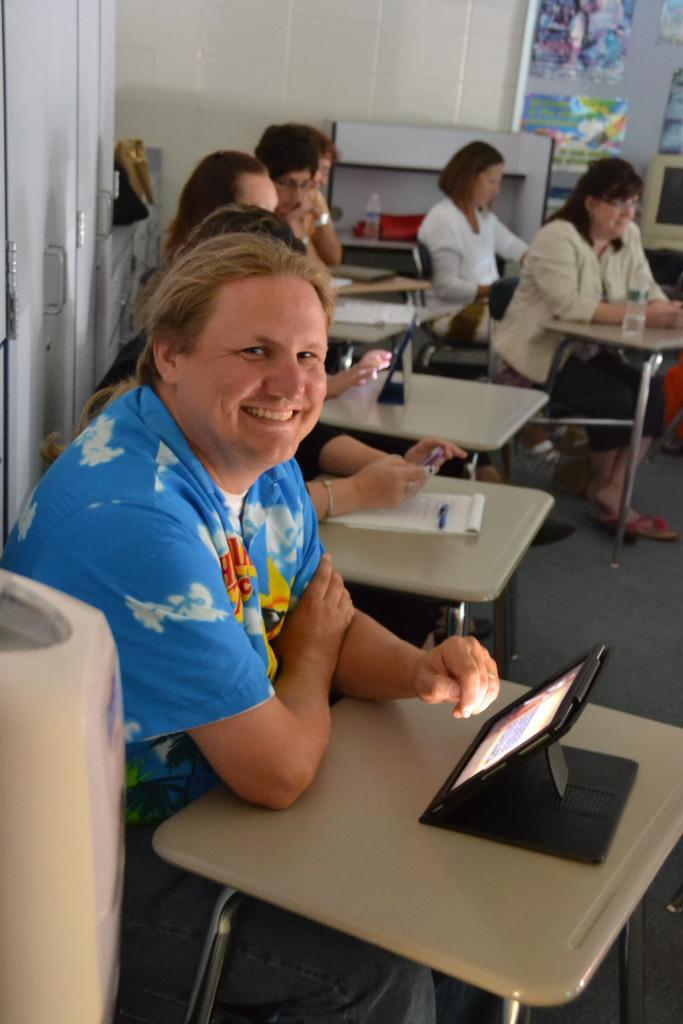In one or two sentences, can you explain what this image depicts? This is the picture of a room. In the foreground there is a person sitting and smiling. At the back there are group of people sitting. There are tabs, books and pen on the table. There is a board on the wall and there is a computer on the table. 